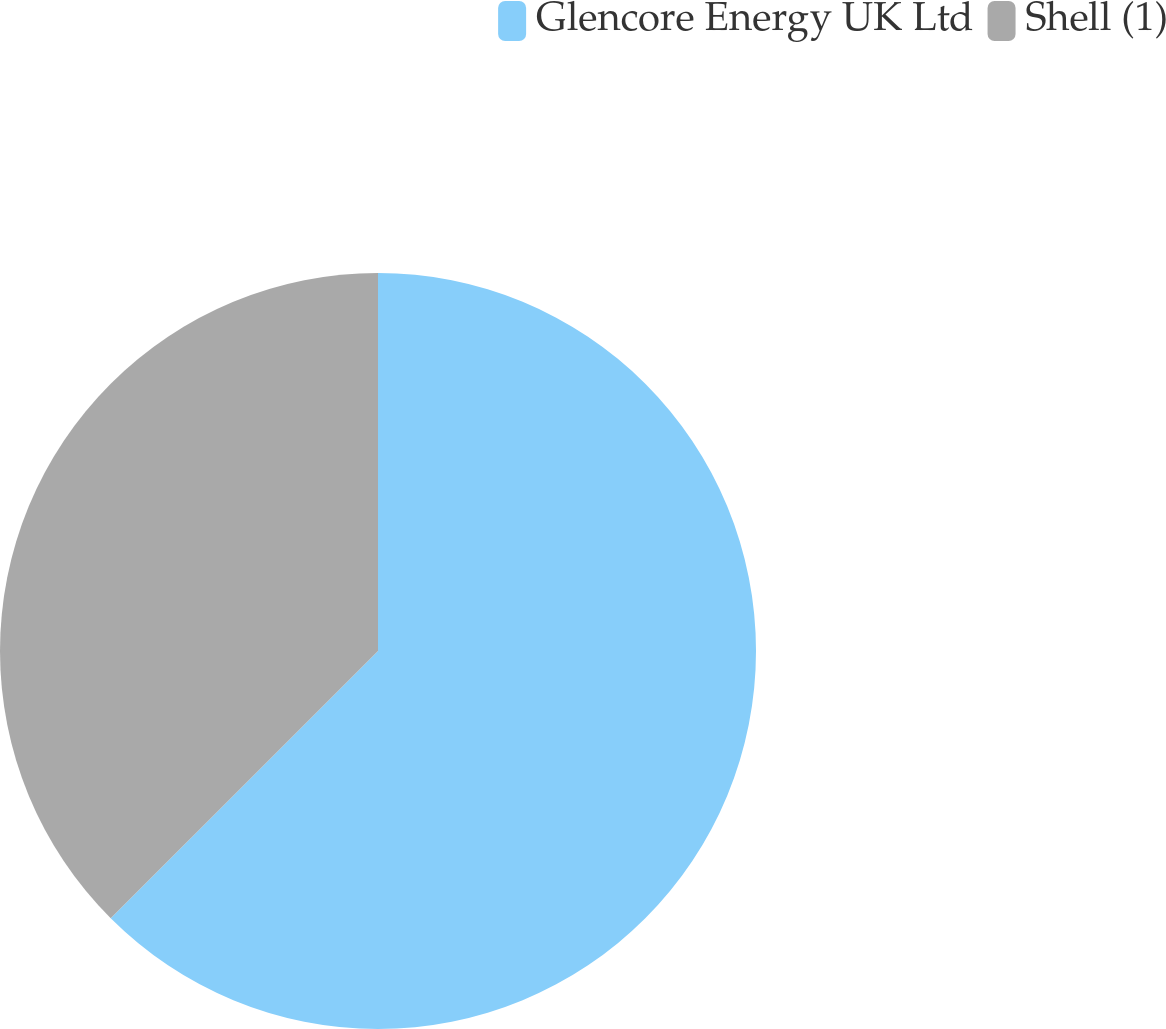<chart> <loc_0><loc_0><loc_500><loc_500><pie_chart><fcel>Glencore Energy UK Ltd<fcel>Shell (1)<nl><fcel>62.5%<fcel>37.5%<nl></chart> 